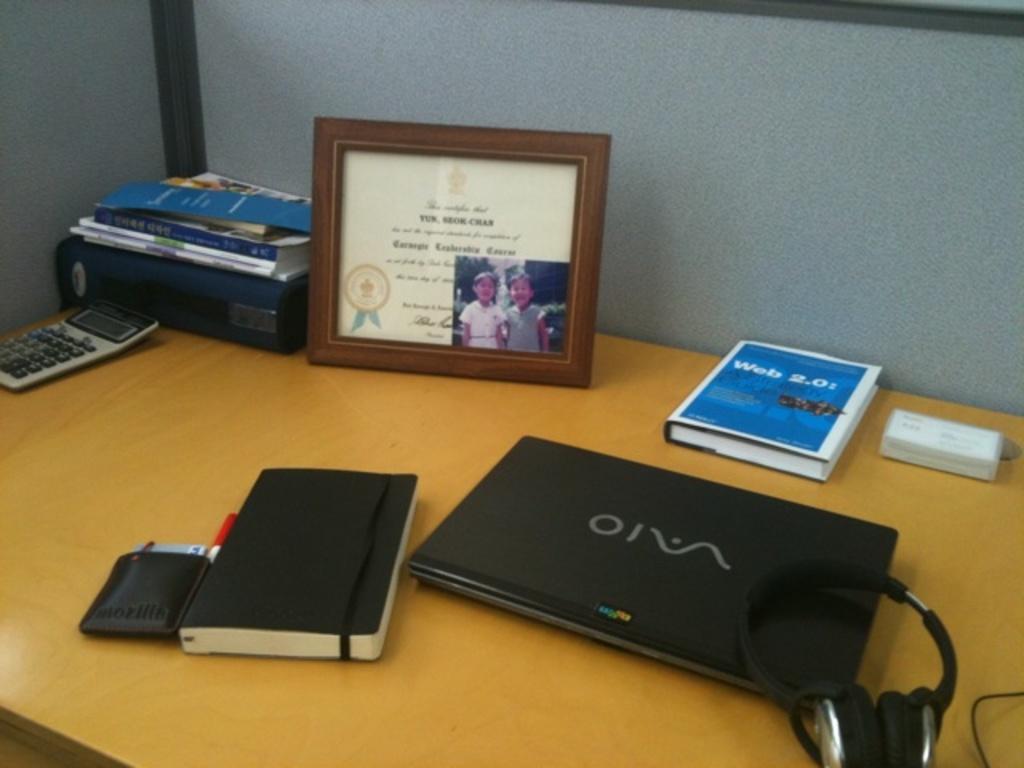What type of laptop is that?
Give a very brief answer. Sony vaio. Whats the title of the book near the back of the desk?
Make the answer very short. Web 2.0. 